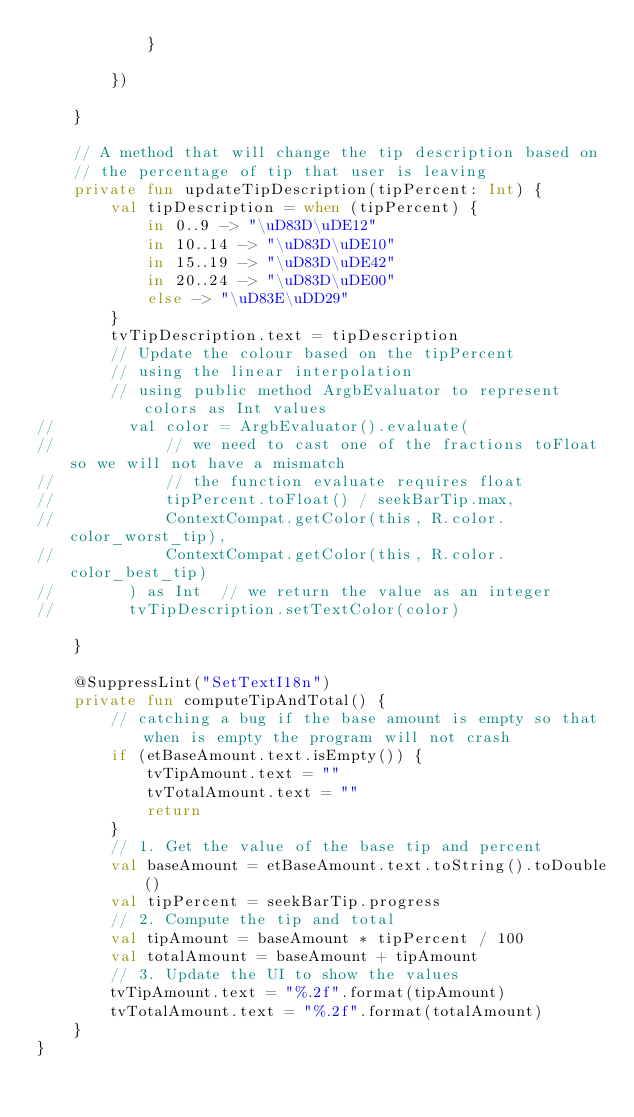<code> <loc_0><loc_0><loc_500><loc_500><_Kotlin_>            }

        })

    }

    // A method that will change the tip description based on
    // the percentage of tip that user is leaving
    private fun updateTipDescription(tipPercent: Int) {
        val tipDescription = when (tipPercent) {
            in 0..9 -> "\uD83D\uDE12"
            in 10..14 -> "\uD83D\uDE10"
            in 15..19 -> "\uD83D\uDE42"
            in 20..24 -> "\uD83D\uDE00"
            else -> "\uD83E\uDD29"
        }
        tvTipDescription.text = tipDescription
        // Update the colour based on the tipPercent
        // using the linear interpolation
        // using public method ArgbEvaluator to represent colors as Int values
//        val color = ArgbEvaluator().evaluate(
//            // we need to cast one of the fractions toFloat so we will not have a mismatch
//            // the function evaluate requires float
//            tipPercent.toFloat() / seekBarTip.max,
//            ContextCompat.getColor(this, R.color.color_worst_tip),
//            ContextCompat.getColor(this, R.color.color_best_tip)
//        ) as Int  // we return the value as an integer
//        tvTipDescription.setTextColor(color)

    }

    @SuppressLint("SetTextI18n")
    private fun computeTipAndTotal() {
        // catching a bug if the base amount is empty so that when is empty the program will not crash
        if (etBaseAmount.text.isEmpty()) {
            tvTipAmount.text = ""
            tvTotalAmount.text = ""
            return
        }
        // 1. Get the value of the base tip and percent
        val baseAmount = etBaseAmount.text.toString().toDouble()
        val tipPercent = seekBarTip.progress
        // 2. Compute the tip and total
        val tipAmount = baseAmount * tipPercent / 100
        val totalAmount = baseAmount + tipAmount
        // 3. Update the UI to show the values
        tvTipAmount.text = "%.2f".format(tipAmount)
        tvTotalAmount.text = "%.2f".format(totalAmount)
    }
}</code> 